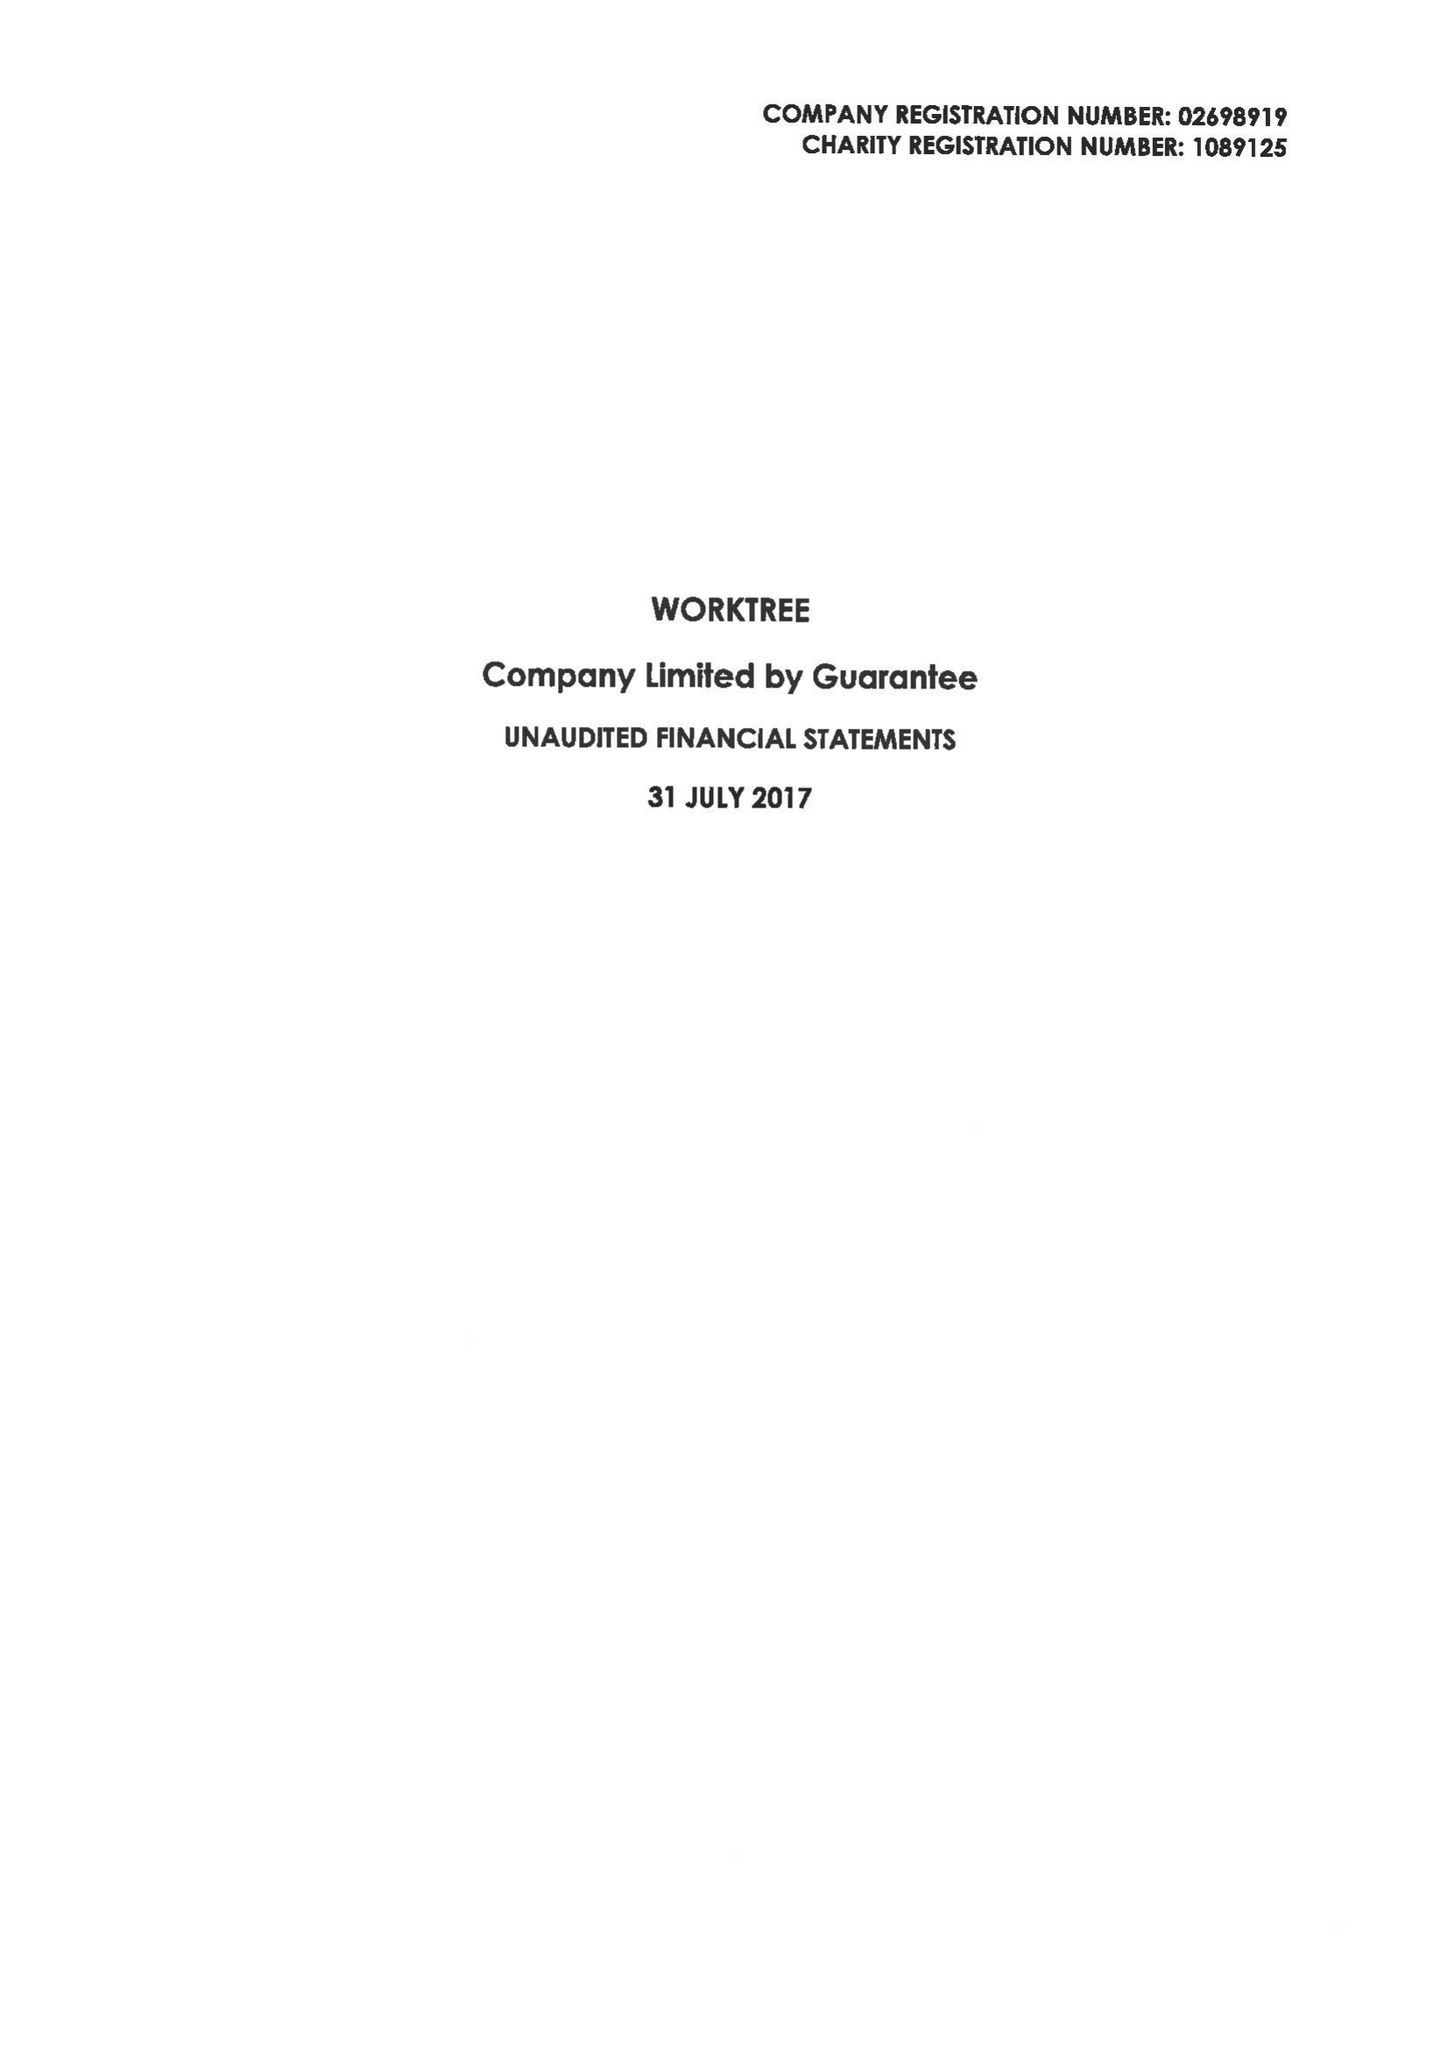What is the value for the address__post_town?
Answer the question using a single word or phrase. MILTON KEYNES 